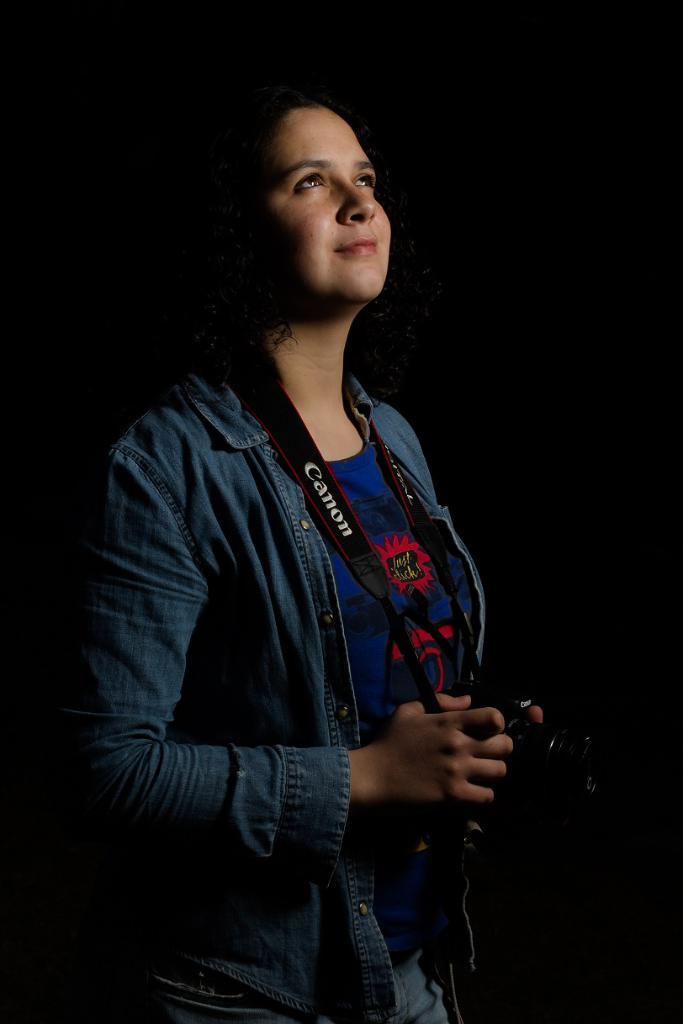Who is the main subject in the image? There is a lady in the image. What is the lady wearing? The lady is wearing a blue jacket. What is the lady holding in her hands? The lady is holding a camera in her hands. What type of magic is the lady performing with the twig in the image? There is no twig or magic present in the image; the lady is holding a camera. 